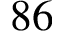<formula> <loc_0><loc_0><loc_500><loc_500>8 6</formula> 